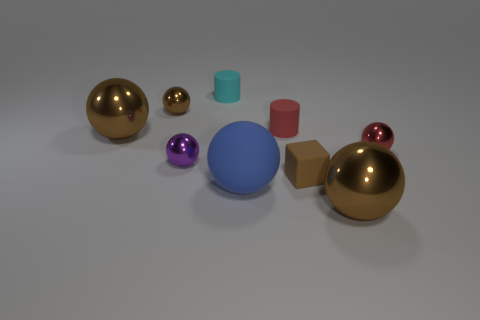Is the shape of the red rubber object the same as the tiny brown metallic object?
Your answer should be very brief. No. There is a cube that is the same size as the purple object; what is its color?
Give a very brief answer. Brown. Is there a tiny object of the same color as the big matte object?
Your answer should be compact. No. Are there any small cyan matte objects?
Keep it short and to the point. Yes. Is the material of the brown sphere in front of the tiny block the same as the purple sphere?
Offer a terse response. Yes. What number of objects have the same size as the block?
Give a very brief answer. 5. Are there an equal number of small red metallic objects that are behind the cyan matte cylinder and brown metal things?
Give a very brief answer. No. How many brown shiny objects are in front of the red sphere and behind the blue sphere?
Keep it short and to the point. 0. The cyan object that is made of the same material as the large blue object is what size?
Provide a short and direct response. Small. What number of red matte things have the same shape as the large blue matte thing?
Offer a terse response. 0. 